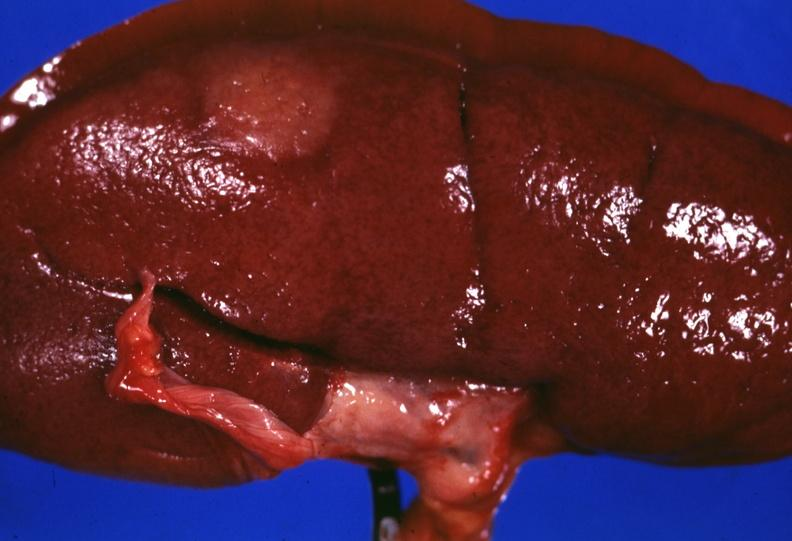s palmar crease normal present?
Answer the question using a single word or phrase. No 